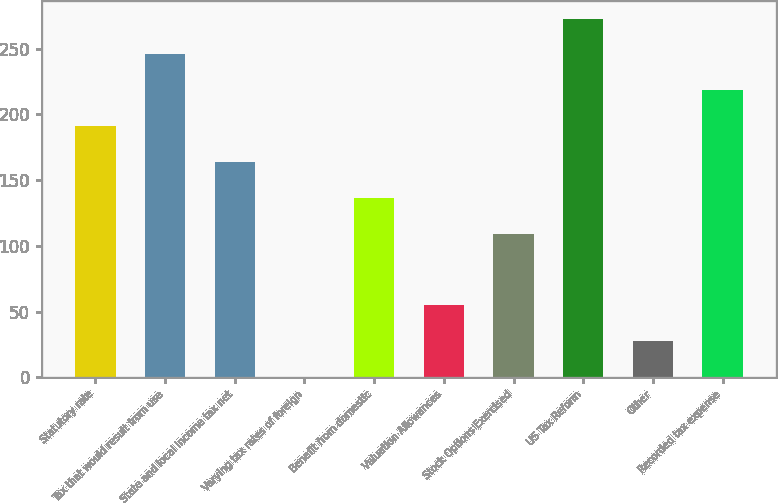Convert chart to OTSL. <chart><loc_0><loc_0><loc_500><loc_500><bar_chart><fcel>Statutory rate<fcel>Tax that would result from use<fcel>State and local income tax net<fcel>Varying tax rates of foreign<fcel>Benefit from domestic<fcel>Valuation Allowances<fcel>Stock Options Exercised<fcel>US Tax Reform<fcel>Other<fcel>Recorded tax expense<nl><fcel>191.06<fcel>245.62<fcel>163.78<fcel>0.1<fcel>136.5<fcel>54.66<fcel>109.22<fcel>272.9<fcel>27.38<fcel>218.34<nl></chart> 